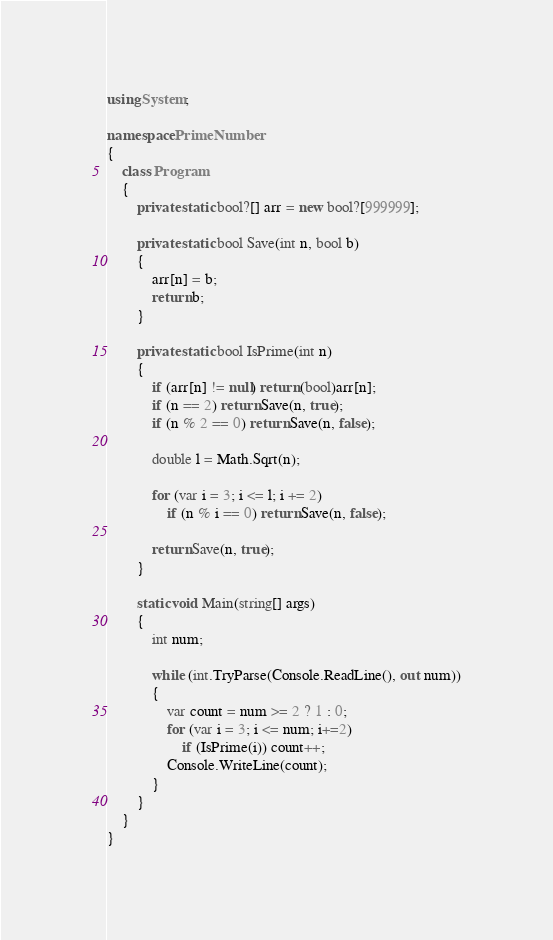Convert code to text. <code><loc_0><loc_0><loc_500><loc_500><_C#_>using System;

namespace PrimeNumber
{
    class Program
    {
        private static bool?[] arr = new bool?[999999];

        private static bool Save(int n, bool b)
        {
            arr[n] = b;
            return b;
        }

        private static bool IsPrime(int n)
        {
            if (arr[n] != null) return (bool)arr[n];
            if (n == 2) return Save(n, true);
            if (n % 2 == 0) return Save(n, false);

            double l = Math.Sqrt(n);

            for (var i = 3; i <= l; i += 2)
                if (n % i == 0) return Save(n, false);
       
            return Save(n, true);
        }

        static void Main(string[] args)
        {
            int num;
            
            while (int.TryParse(Console.ReadLine(), out num))
            {
                var count = num >= 2 ? 1 : 0;
                for (var i = 3; i <= num; i+=2)
                    if (IsPrime(i)) count++;
                Console.WriteLine(count);
            }
        }
    }
}
</code> 